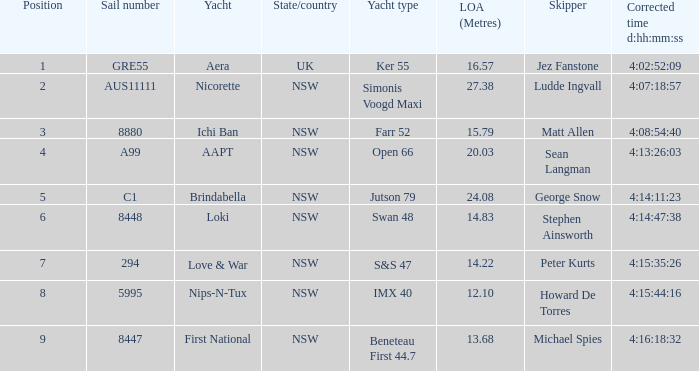For a boat with the correct time of 4:15:35:26, what is the complete sail distance? 14.22. 